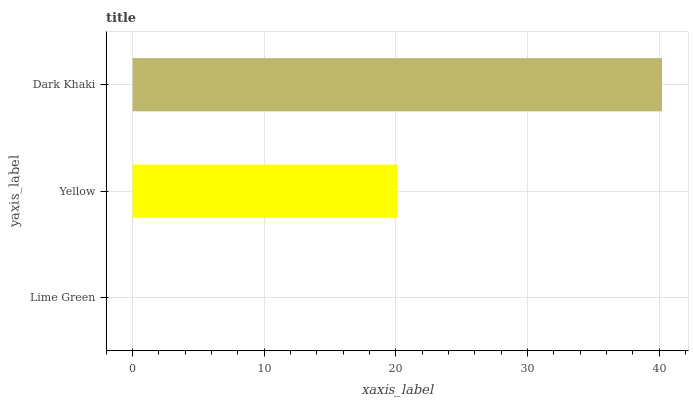Is Lime Green the minimum?
Answer yes or no. Yes. Is Dark Khaki the maximum?
Answer yes or no. Yes. Is Yellow the minimum?
Answer yes or no. No. Is Yellow the maximum?
Answer yes or no. No. Is Yellow greater than Lime Green?
Answer yes or no. Yes. Is Lime Green less than Yellow?
Answer yes or no. Yes. Is Lime Green greater than Yellow?
Answer yes or no. No. Is Yellow less than Lime Green?
Answer yes or no. No. Is Yellow the high median?
Answer yes or no. Yes. Is Yellow the low median?
Answer yes or no. Yes. Is Lime Green the high median?
Answer yes or no. No. Is Dark Khaki the low median?
Answer yes or no. No. 